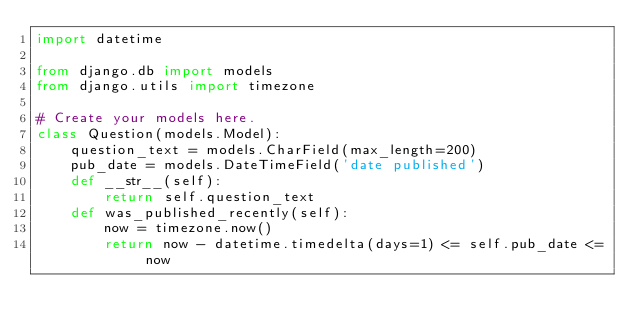<code> <loc_0><loc_0><loc_500><loc_500><_Python_>import datetime

from django.db import models
from django.utils import timezone

# Create your models here.
class Question(models.Model):
    question_text = models.CharField(max_length=200)
    pub_date = models.DateTimeField('date published')
    def __str__(self):
        return self.question_text
    def was_published_recently(self):
        now = timezone.now()
        return now - datetime.timedelta(days=1) <= self.pub_date <= now</code> 